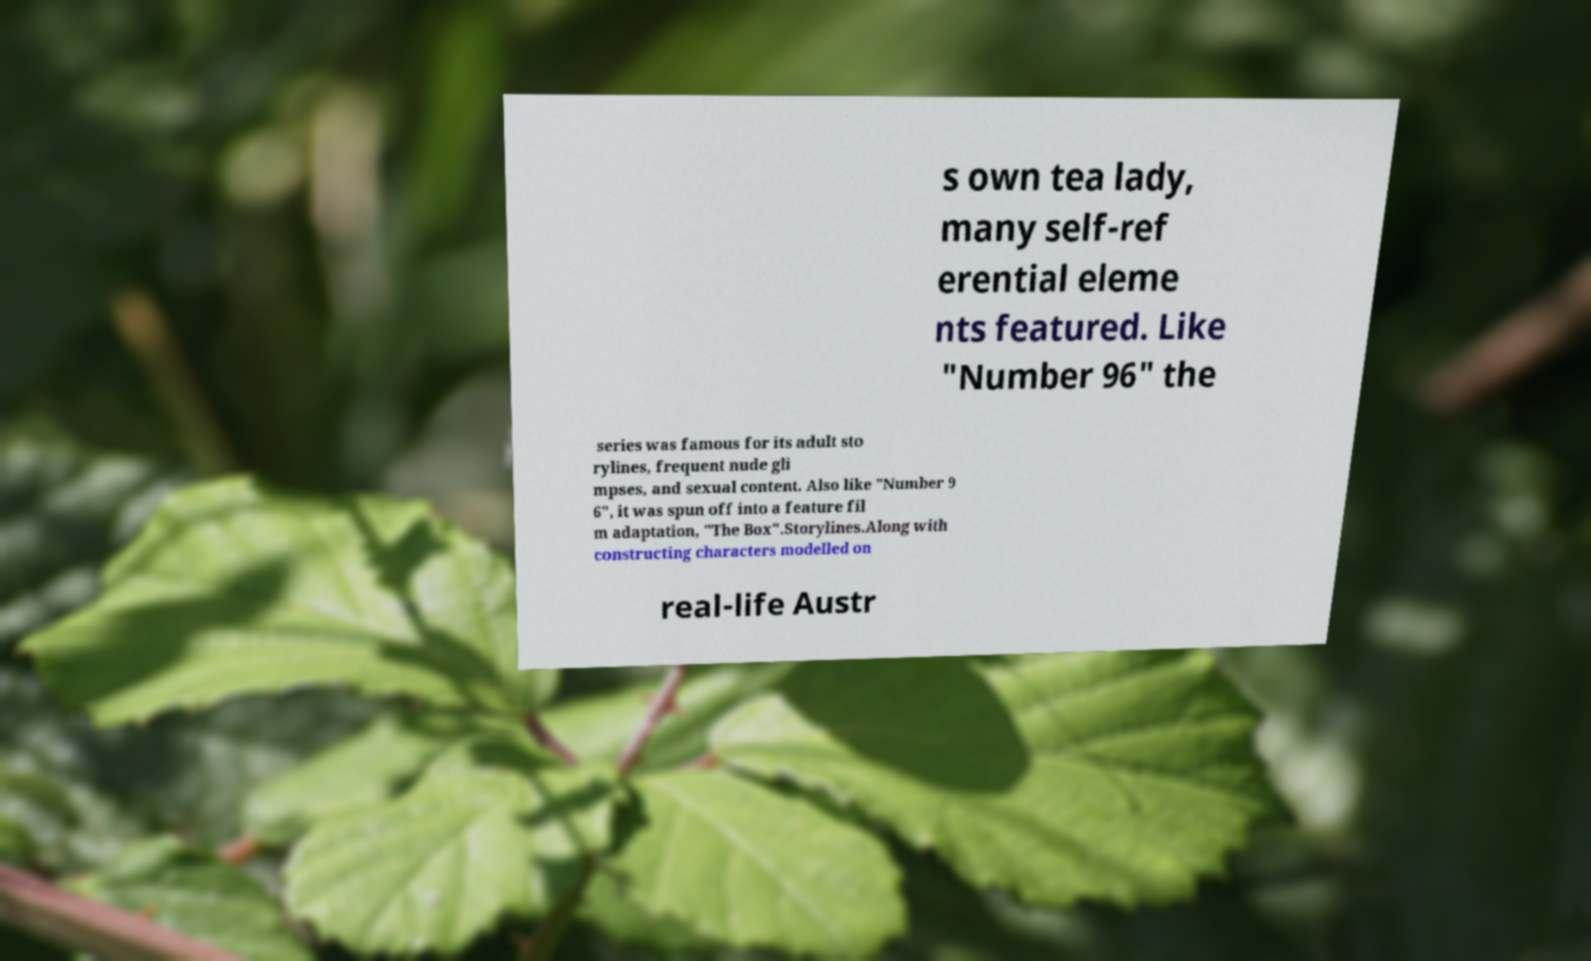There's text embedded in this image that I need extracted. Can you transcribe it verbatim? s own tea lady, many self-ref erential eleme nts featured. Like "Number 96" the series was famous for its adult sto rylines, frequent nude gli mpses, and sexual content. Also like "Number 9 6", it was spun off into a feature fil m adaptation, "The Box".Storylines.Along with constructing characters modelled on real-life Austr 